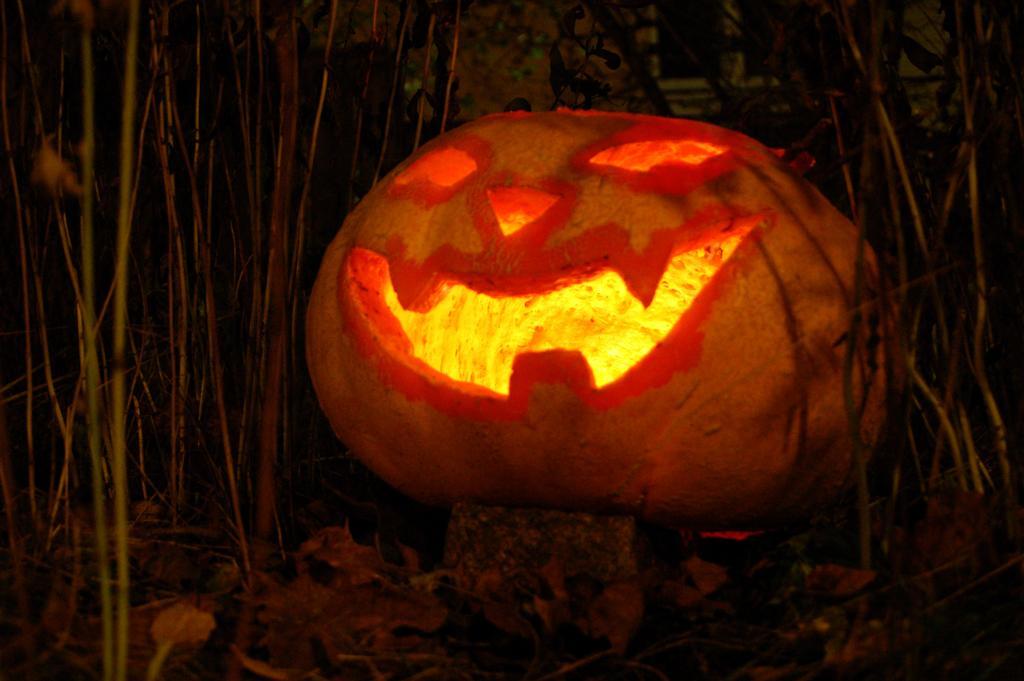Can you describe this image briefly? In this image we can see pumpkin with carvings. Also there is light inside the pumpkin. On the ground there are dried leaves and stems. In the background it is dark. 